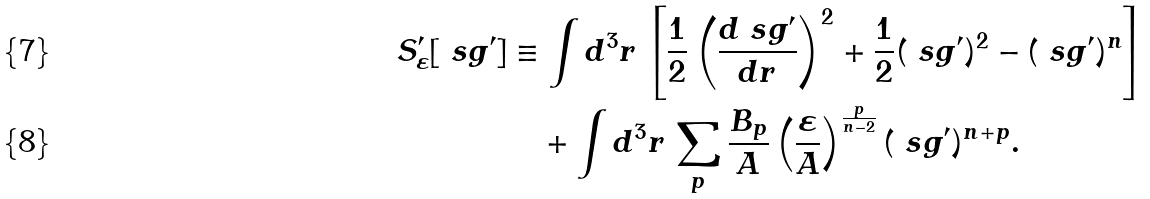Convert formula to latex. <formula><loc_0><loc_0><loc_500><loc_500>S _ { \varepsilon } ^ { \prime } [ \ s g ^ { \prime } ] & \equiv \int d ^ { 3 } r \, \left [ \frac { 1 } { 2 } \left ( \frac { d \ s g ^ { \prime } } { d r } \right ) ^ { 2 } + \frac { 1 } { 2 } ( \ s g ^ { \prime } ) ^ { 2 } - ( \ s g ^ { \prime } ) ^ { n } \right ] \\ & \quad + \int d ^ { 3 } r \, \sum _ { p } \frac { B _ { p } } { A } \left ( \frac { \varepsilon } { A } \right ) ^ { \frac { p } { n - 2 } } ( \ s g ^ { \prime } ) ^ { n + p } .</formula> 